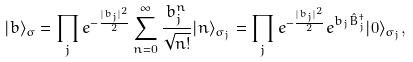<formula> <loc_0><loc_0><loc_500><loc_500>| b \rangle _ { \sigma } = \prod _ { j } e ^ { - { \frac { | b _ { j } | ^ { 2 } } { 2 } } } \sum _ { n = 0 } ^ { \infty } { \frac { b _ { j } ^ { n } } { \sqrt { n ! } } } | n \rangle _ { \sigma _ { j } } = \prod _ { j } e ^ { - { \frac { | b _ { j } | ^ { 2 } } { 2 } } } e ^ { b _ { j } \hat { B } _ { j } ^ { \dagger } } | 0 \rangle _ { \sigma _ { j } } ,</formula> 